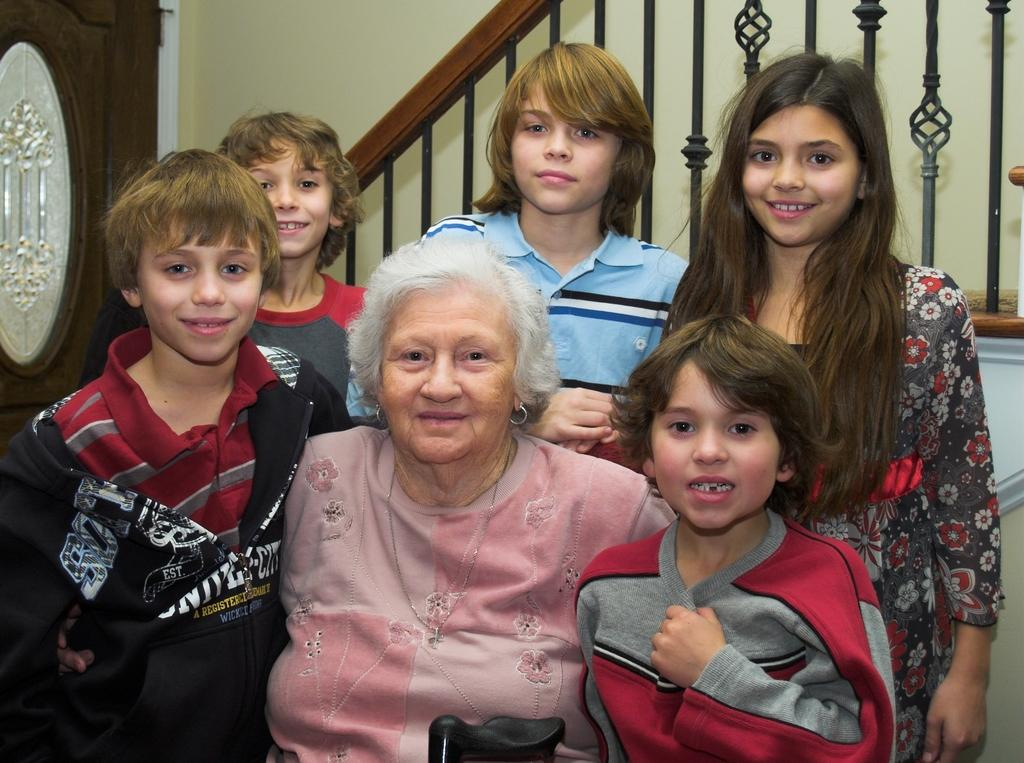What is the main subject of the image? The main subject of the image is a group of people in the middle of the image. What can be seen in the background of the image? There is an iron grill in the background of the image. What is located on the left side of the image? There appears to be a cupboard on the left side of the image. What type of note is being passed between the people in the image? There is no note being passed between the people in the image; they are simply standing together. What is the group of people's shared interest in the image? The image does not provide information about the group's shared interests. 